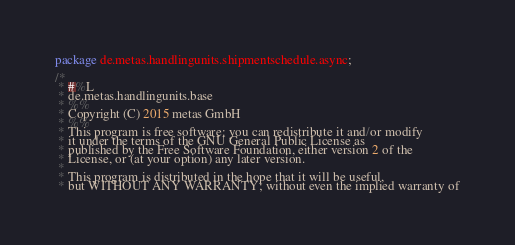<code> <loc_0><loc_0><loc_500><loc_500><_Java_>package de.metas.handlingunits.shipmentschedule.async;

/*
 * #%L
 * de.metas.handlingunits.base
 * %%
 * Copyright (C) 2015 metas GmbH
 * %%
 * This program is free software: you can redistribute it and/or modify
 * it under the terms of the GNU General Public License as
 * published by the Free Software Foundation, either version 2 of the
 * License, or (at your option) any later version.
 * 
 * This program is distributed in the hope that it will be useful,
 * but WITHOUT ANY WARRANTY; without even the implied warranty of</code> 